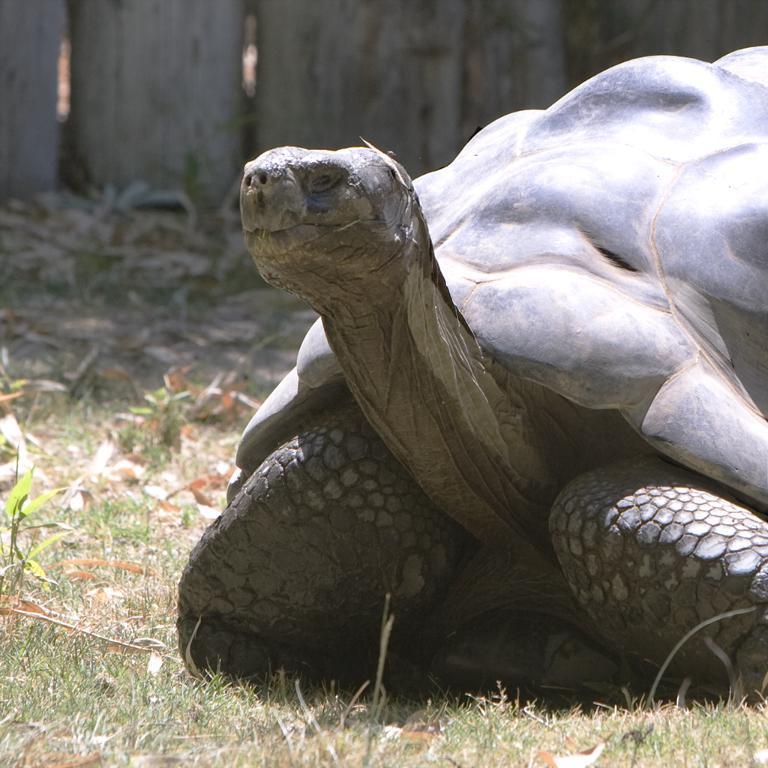How would you summarize this image in a sentence or two? In this image I can see a big tortoise, on the left side there is a grass. At the top it looks like a wooden fencing. 